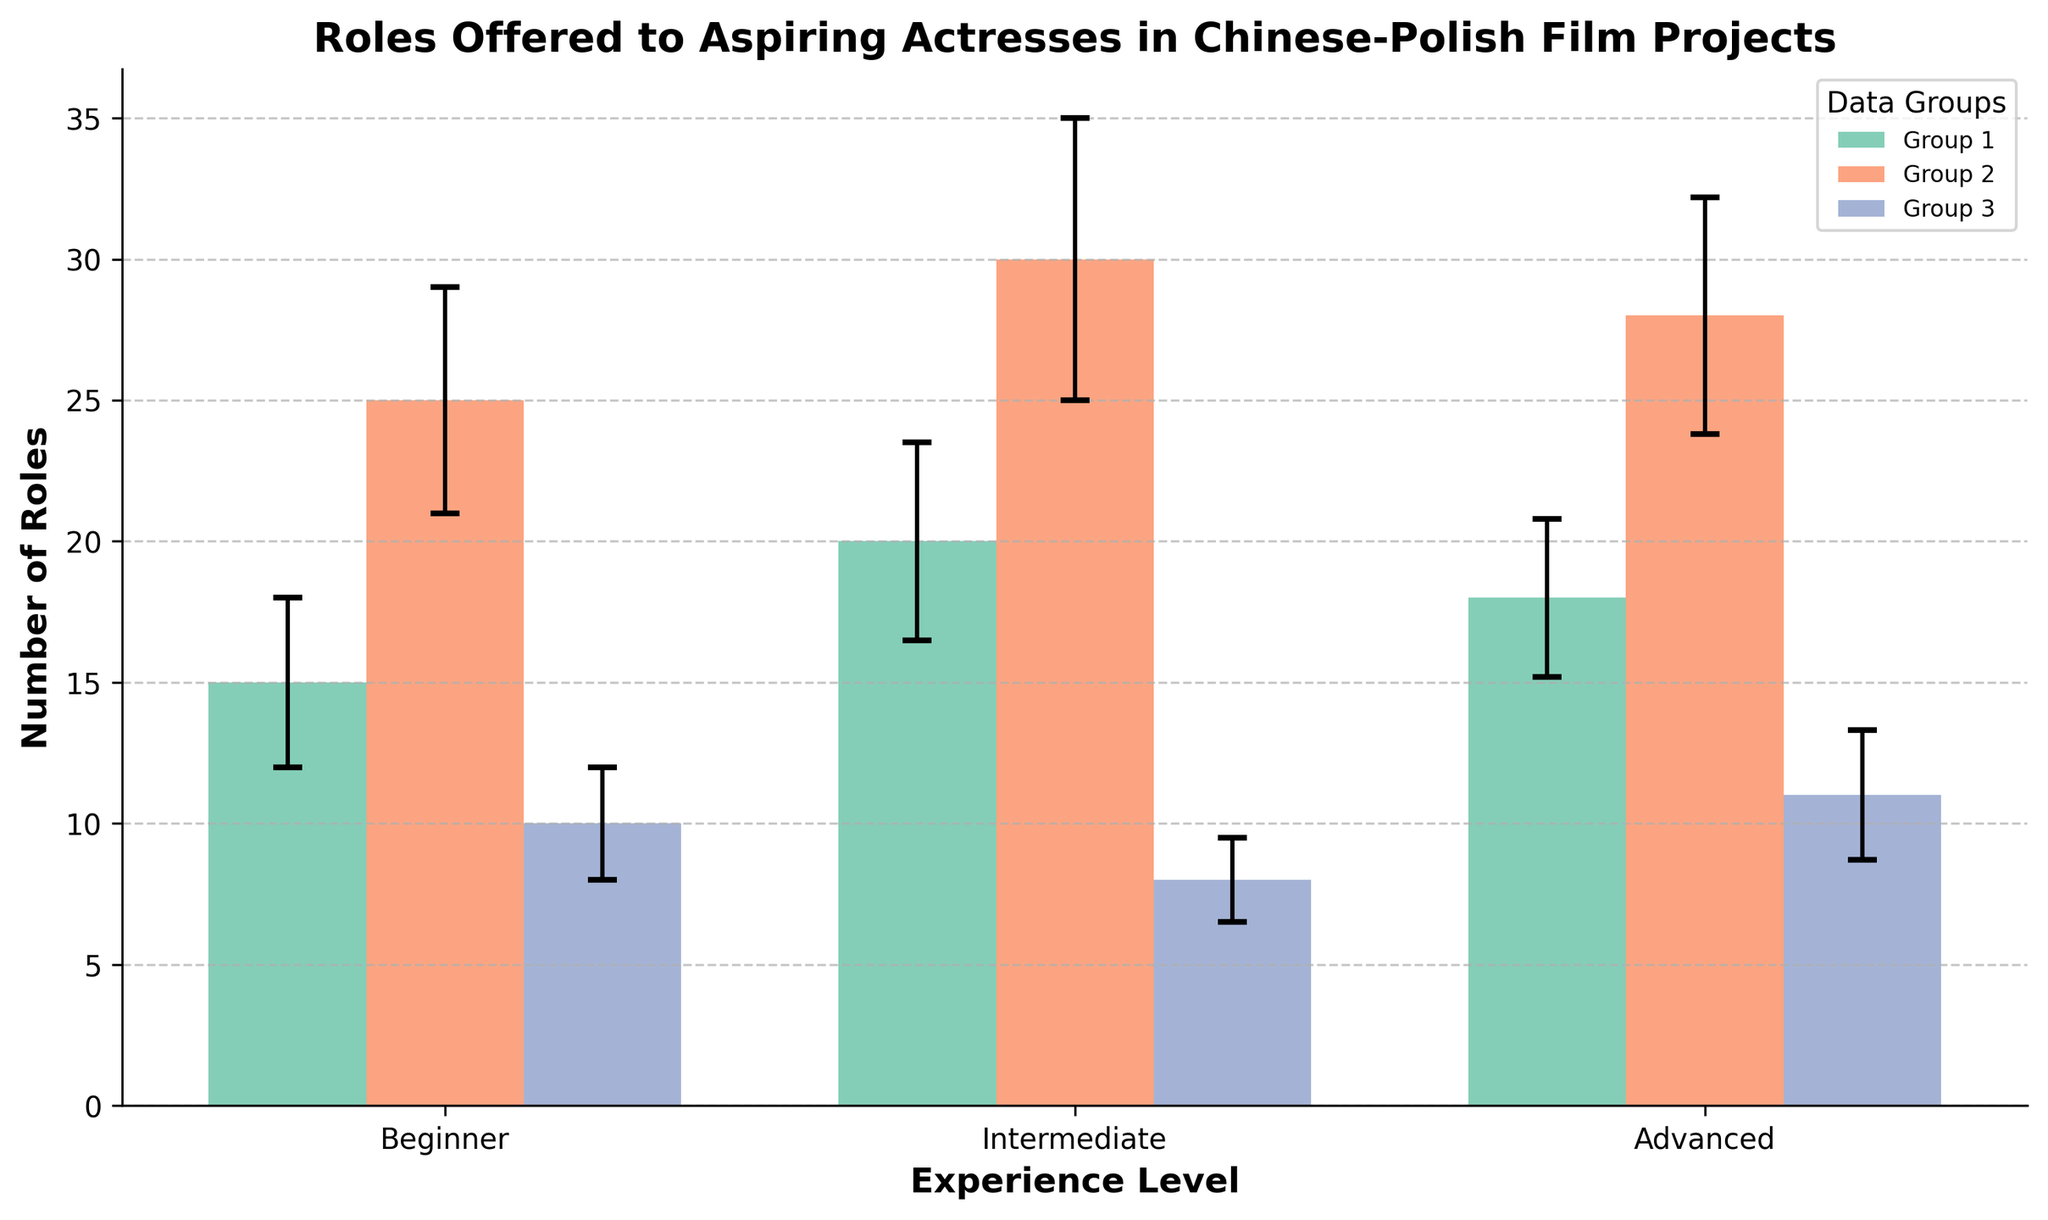What is the title of the plot? The title of the plot is written at the top of the figure. It reads "Roles Offered to Aspiring Actresses in Chinese-Polish Film Projects".
Answer: Roles Offered to Aspiring Actresses in Chinese-Polish Film Projects What is the average number of roles offered to the intermediate group? To find the average, sum the number of roles offered to the intermediate group and divide by the number of data points. So, (25 + 30 + 28) / 3 = 83 / 3.
Answer: 27.67 Which experience level had the highest variability in the number of roles offered? The variability of each group can be determined by looking at the length of the error bars. The intermediate group has the largest standard deviations (4, 5, and 4.2).
Answer: Intermediate How many experience levels are shown in the plot? The experience levels are labeled on the x-axis as Beginner, Intermediate, and Advanced. There are three levels shown.
Answer: 3 Which group has the smallest average number of roles offered? Calculate the average for each group: Beginner (15 + 20 + 18) / 3 = 17.67, Intermediate (25 + 30 + 28) / 3 = 27.67, Advanced (10 + 8 + 11) / 3 = 9.67. The Advanced group has the smallest average number of roles offered.
Answer: Advanced What is the largest number of roles offered to the beginner group? The number of roles offered to the beginner group can be directly read off the figure. The highest value among these is 20.
Answer: 20 Compare the range of roles offered to beginners vs advanced actresses. Range is the difference between the highest and lowest values. For beginners: 20 - 15 = 5. For advanced: 11 - 8 = 3. Beginners have a larger range.
Answer: Beginners What's the total number of roles offered to the intermediate group? Sum the number of roles offered to the intermediate group: 25 + 30 + 28 = 83.
Answer: 83 What can we infer about the experience level with the smallest error bars on average? The error bars indicate variability. Small error bars suggest less variability. The values for each group’s error bars are: Beginner (3, 3.5, 2.8), Intermediate (4, 5, 4.2), Advanced (2, 1.5, 2.3). Advanced actresses show the smallest average error.
Answer: Advanced 